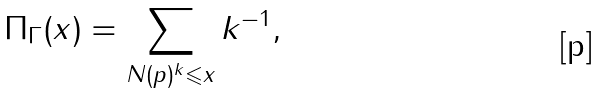Convert formula to latex. <formula><loc_0><loc_0><loc_500><loc_500>\Pi _ { \Gamma } ( x ) = \sum _ { N ( p ) ^ { k } \leqslant x } k ^ { - 1 } ,</formula> 